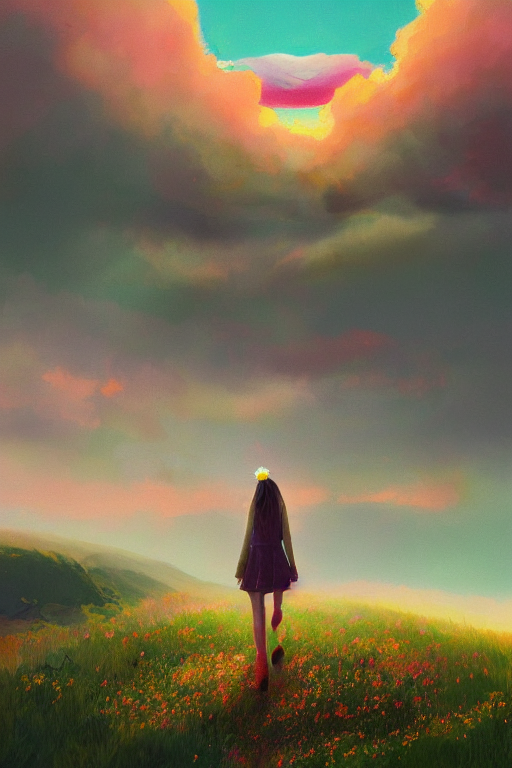What time of day does this image represent? The image likely represents sunset, given the warm colors and the soft golden light that seems to radiate from the horizon. The clouds are illuminated from below, which is characteristic of the sun's position just below the skyline during dusk. 